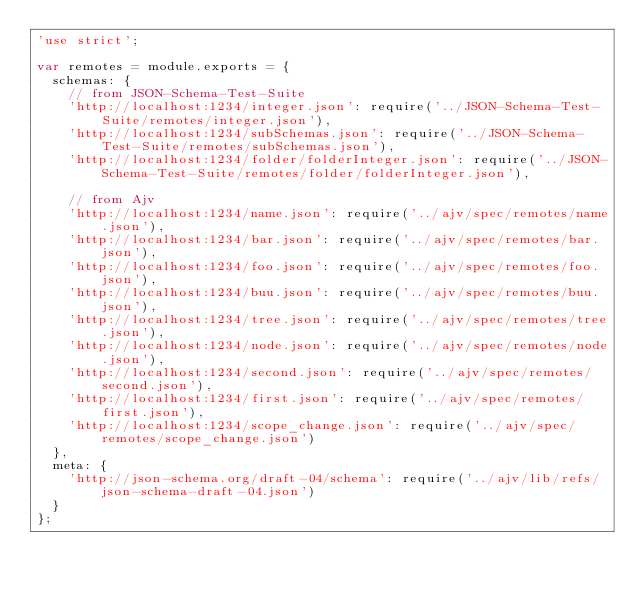Convert code to text. <code><loc_0><loc_0><loc_500><loc_500><_JavaScript_>'use strict';

var remotes = module.exports = {
  schemas: {
    // from JSON-Schema-Test-Suite
    'http://localhost:1234/integer.json': require('../JSON-Schema-Test-Suite/remotes/integer.json'),
    'http://localhost:1234/subSchemas.json': require('../JSON-Schema-Test-Suite/remotes/subSchemas.json'),
    'http://localhost:1234/folder/folderInteger.json': require('../JSON-Schema-Test-Suite/remotes/folder/folderInteger.json'),

    // from Ajv
    'http://localhost:1234/name.json': require('../ajv/spec/remotes/name.json'),
    'http://localhost:1234/bar.json': require('../ajv/spec/remotes/bar.json'),
    'http://localhost:1234/foo.json': require('../ajv/spec/remotes/foo.json'),
    'http://localhost:1234/buu.json': require('../ajv/spec/remotes/buu.json'),
    'http://localhost:1234/tree.json': require('../ajv/spec/remotes/tree.json'),
    'http://localhost:1234/node.json': require('../ajv/spec/remotes/node.json'),
    'http://localhost:1234/second.json': require('../ajv/spec/remotes/second.json'),
    'http://localhost:1234/first.json': require('../ajv/spec/remotes/first.json'),
    'http://localhost:1234/scope_change.json': require('../ajv/spec/remotes/scope_change.json')
  },
  meta: {
    'http://json-schema.org/draft-04/schema': require('../ajv/lib/refs/json-schema-draft-04.json')
  }
};
</code> 